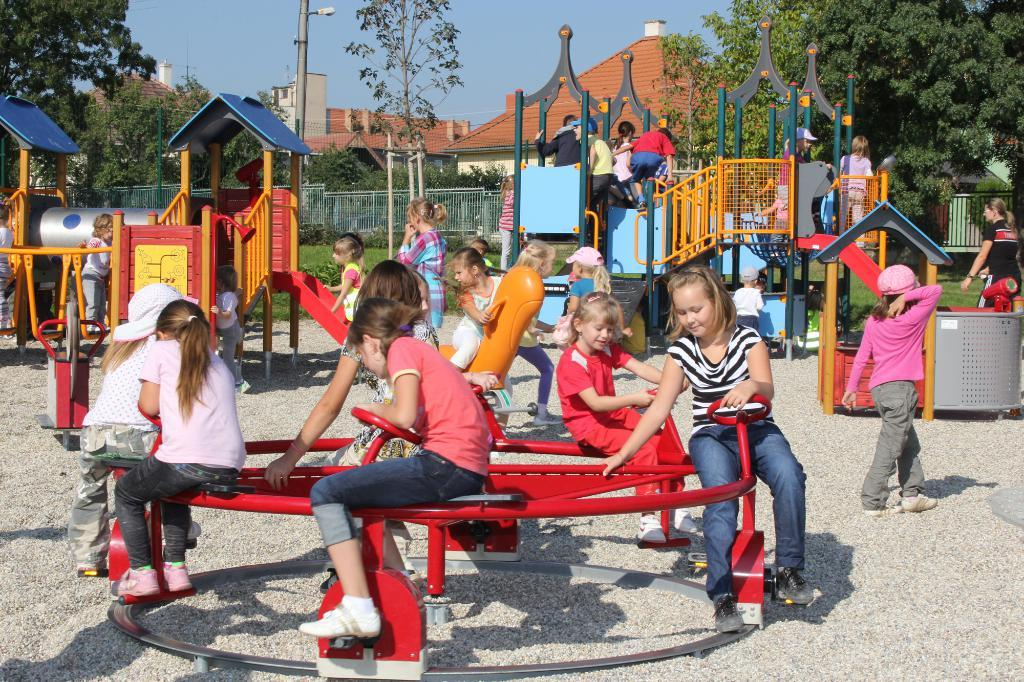What are the people in the image doing? The people in the image are playing outdoor games. What can be seen in the background of the image? There are trees, buildings, a pole, and the sky visible in the background of the image. What type of barrier is present in the image? There is a fence in the image. What type of hand can be seen holding a water bottle in the image? There is no hand or water bottle present in the image. What is the cause of the people playing outdoor games in the image? The provided facts do not mention a cause for the people playing outdoor games in the image. 